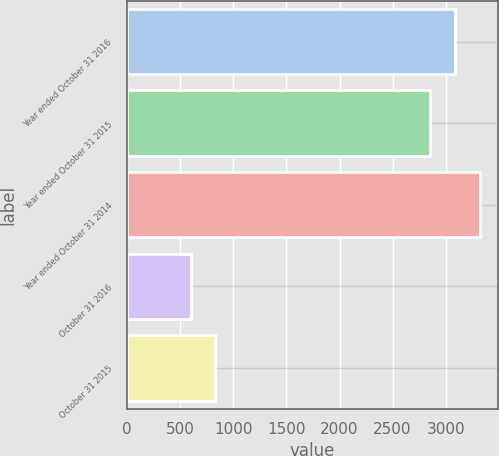<chart> <loc_0><loc_0><loc_500><loc_500><bar_chart><fcel>Year ended October 31 2016<fcel>Year ended October 31 2015<fcel>Year ended October 31 2014<fcel>October 31 2016<fcel>October 31 2015<nl><fcel>3089.5<fcel>2856<fcel>3323<fcel>598<fcel>831.5<nl></chart> 